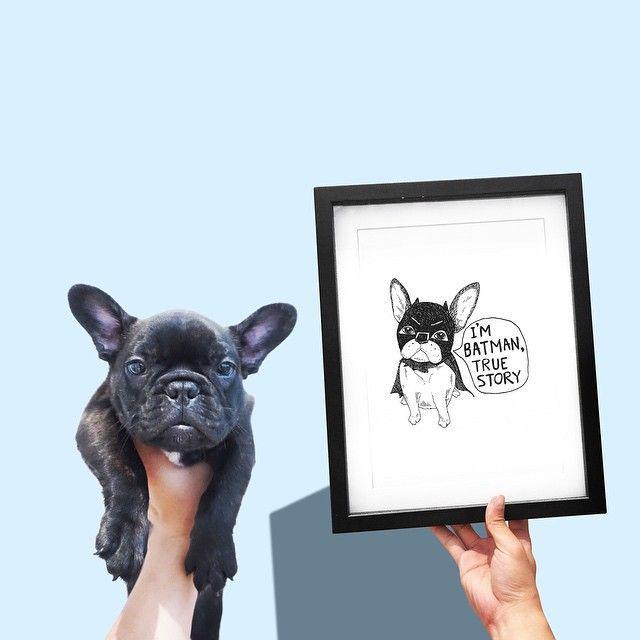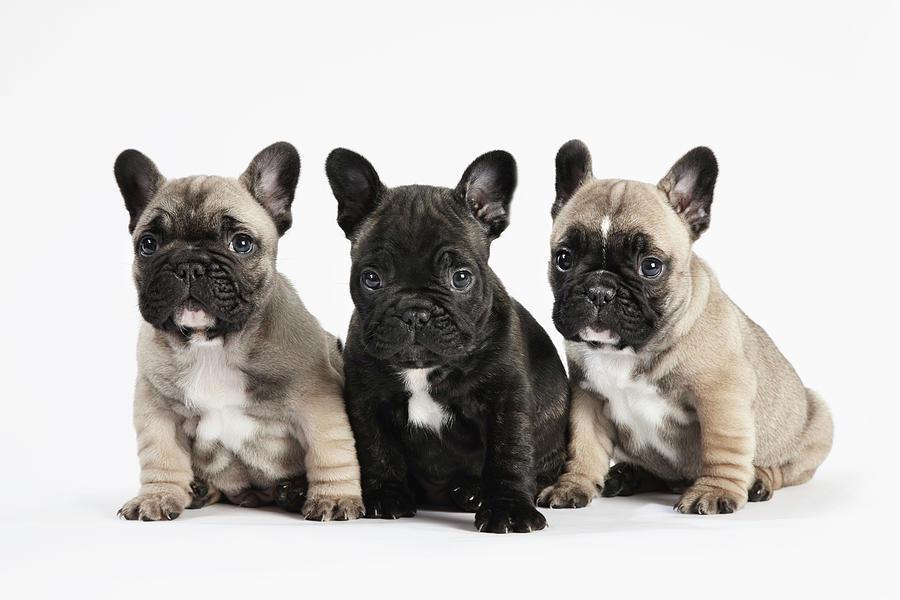The first image is the image on the left, the second image is the image on the right. Assess this claim about the two images: "There are  3 dogs sitting with white fur on their chest.". Correct or not? Answer yes or no. Yes. The first image is the image on the left, the second image is the image on the right. Examine the images to the left and right. Is the description "A single black dog is opposite at least three dogs of multiple colors." accurate? Answer yes or no. Yes. 